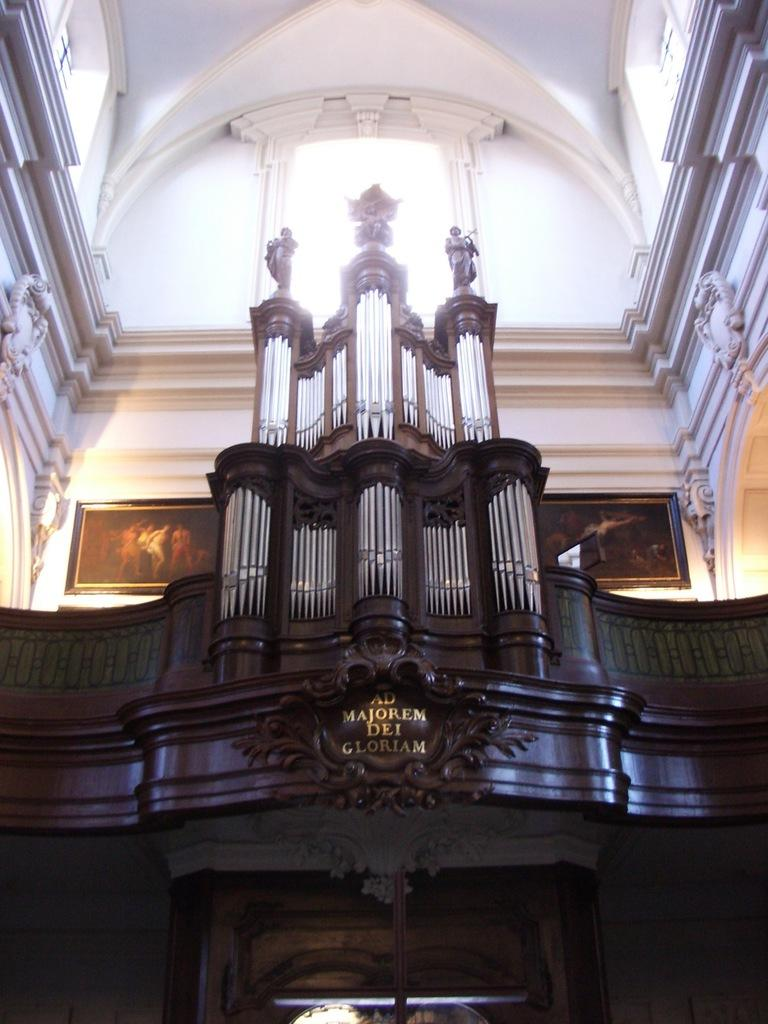What type of building is shown in the image? The image shows an inside view of a church. What can be seen inside the church? There is a wooden structure in the church. What is on top of the wooden structure? There are three symbols on top of the wooden structure. What is visible in the background of the image? There is a wall with two photo frames in the background. How much money is being exchanged in the image? There is no mention of money or any exchange of money in the image. 